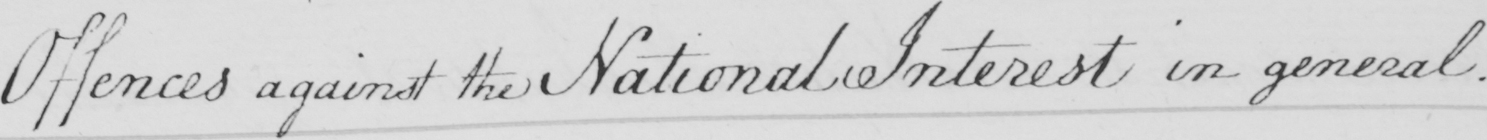Please provide the text content of this handwritten line. Offences against the National Interest in general . 